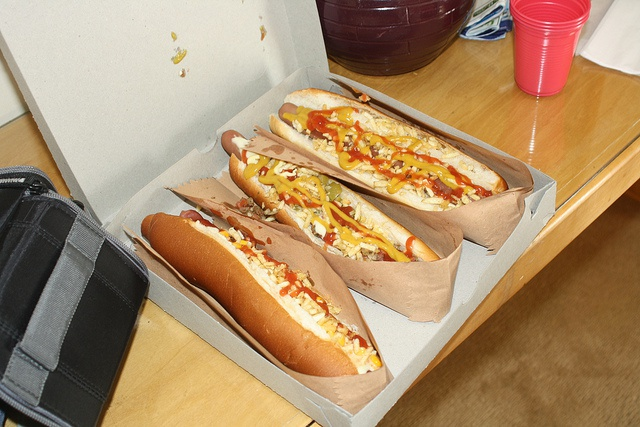Describe the objects in this image and their specific colors. I can see dining table in lightgray, orange, olive, and tan tones, hot dog in lightgray, brown, orange, khaki, and red tones, hot dog in lightgray, tan, orange, and red tones, hot dog in lightgray, khaki, orange, tan, and brown tones, and bowl in lightgray, maroon, black, and gray tones in this image. 